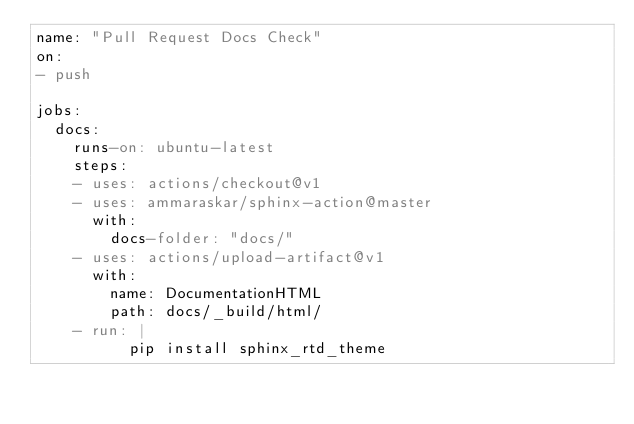Convert code to text. <code><loc_0><loc_0><loc_500><loc_500><_YAML_>name: "Pull Request Docs Check"
on: 
- push

jobs:
  docs:
    runs-on: ubuntu-latest
    steps:
    - uses: actions/checkout@v1
    - uses: ammaraskar/sphinx-action@master
      with:
        docs-folder: "docs/"
    - uses: actions/upload-artifact@v1
      with:
        name: DocumentationHTML
        path: docs/_build/html/ 
    - run: |
          pip install sphinx_rtd_theme
    
</code> 